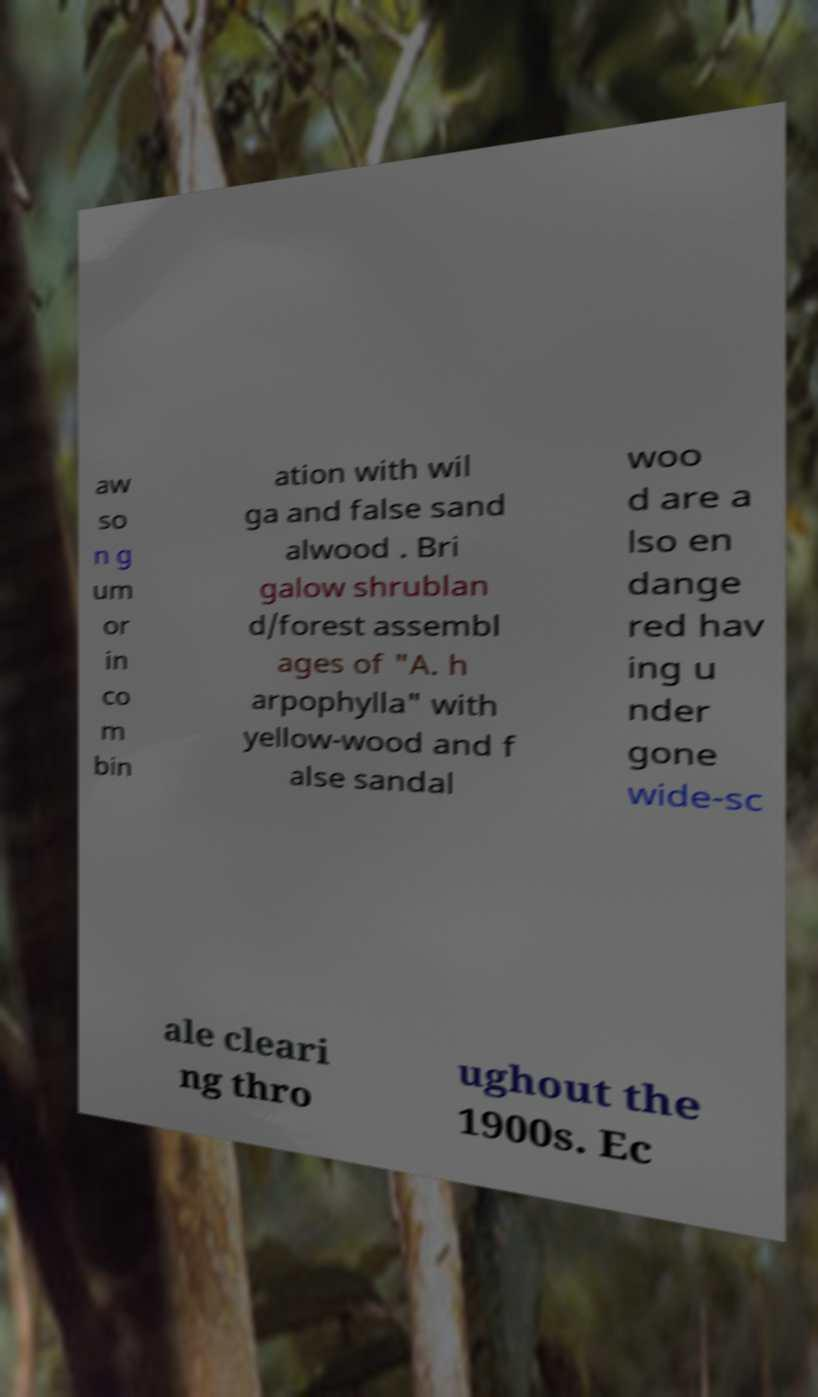What messages or text are displayed in this image? I need them in a readable, typed format. aw so n g um or in co m bin ation with wil ga and false sand alwood . Bri galow shrublan d/forest assembl ages of "A. h arpophylla" with yellow-wood and f alse sandal woo d are a lso en dange red hav ing u nder gone wide-sc ale cleari ng thro ughout the 1900s. Ec 